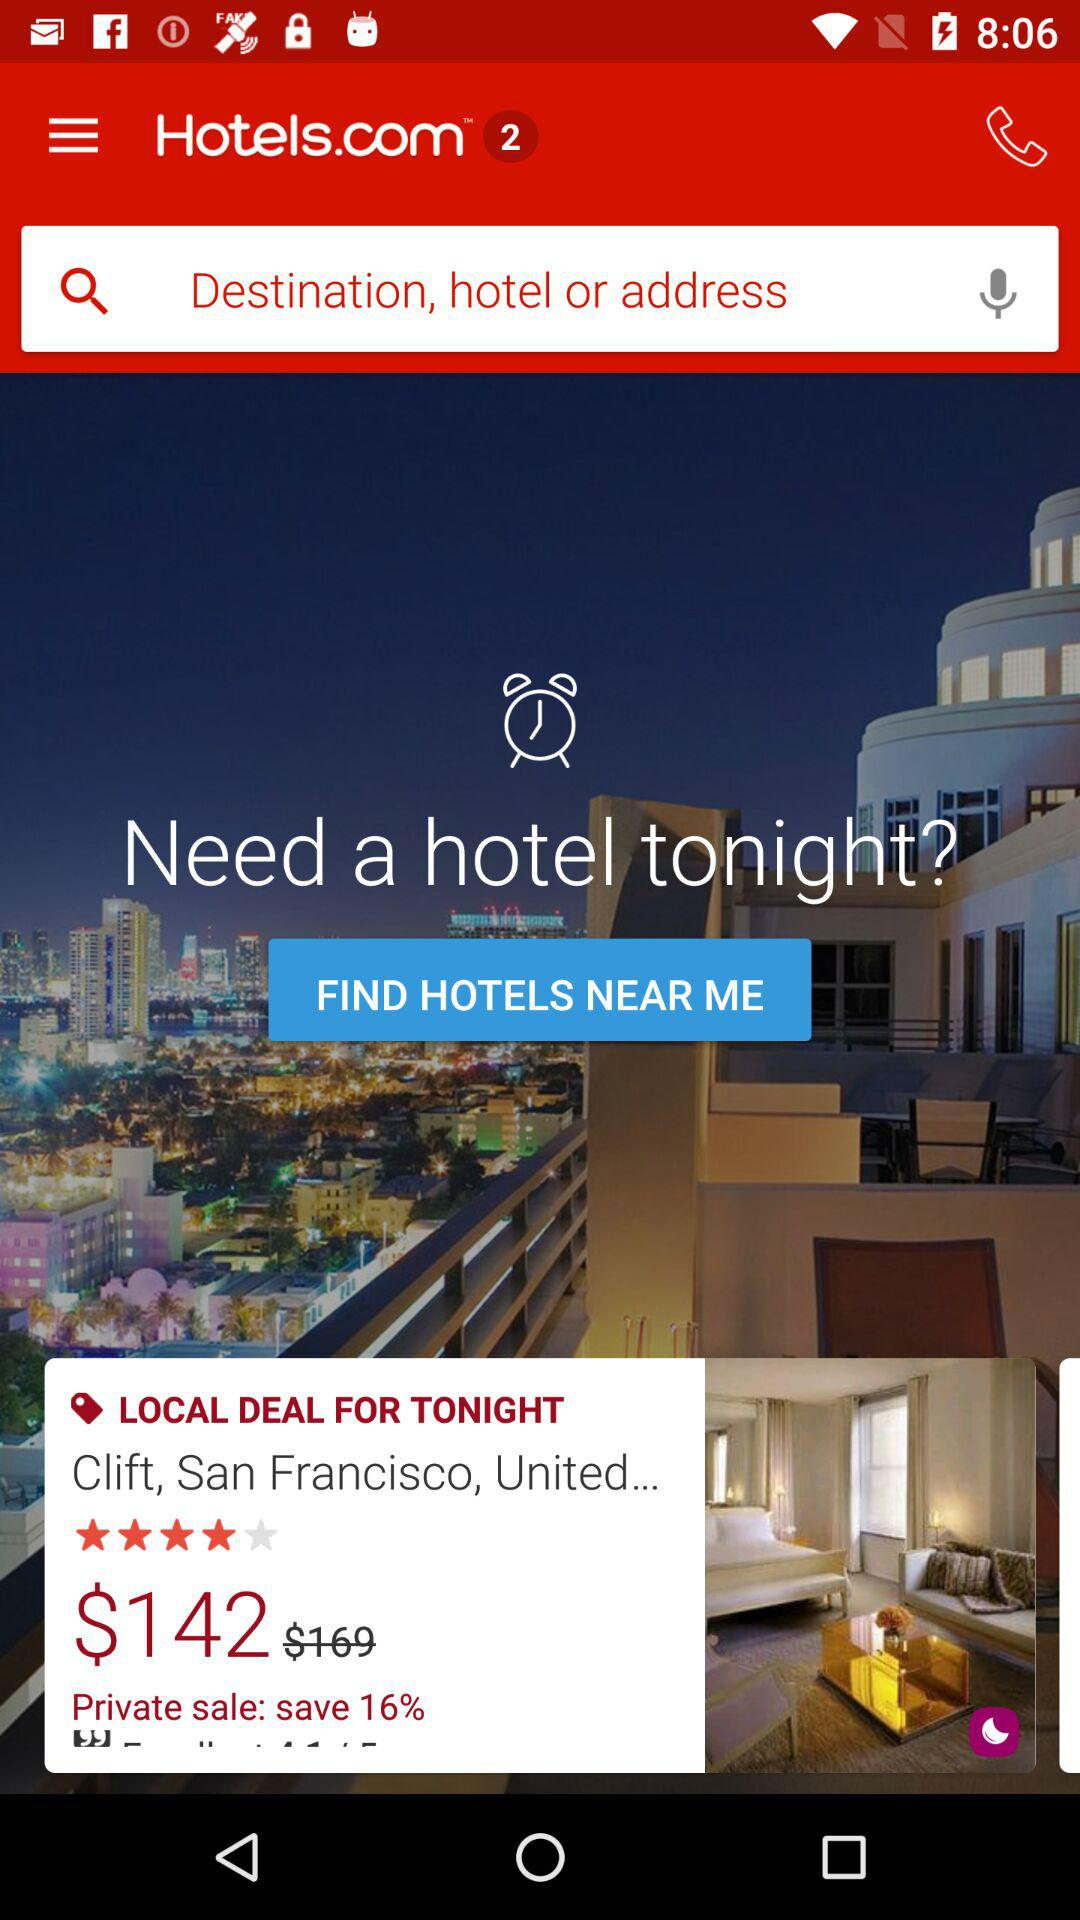Which days of the week are selected for staying at the hotel?
When the provided information is insufficient, respond with <no answer>. <no answer> 